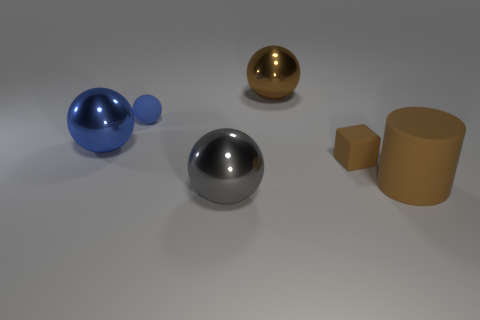Does the small brown object have the same material as the cylinder? Based on the image, while both the small brown object and the cylinder appear to have a matte finish, they are not of the same material. The small brown object seems to resemble a cardboard-like texture, whereas the cylinder appears to have a more metallic or plastic-like composition. 